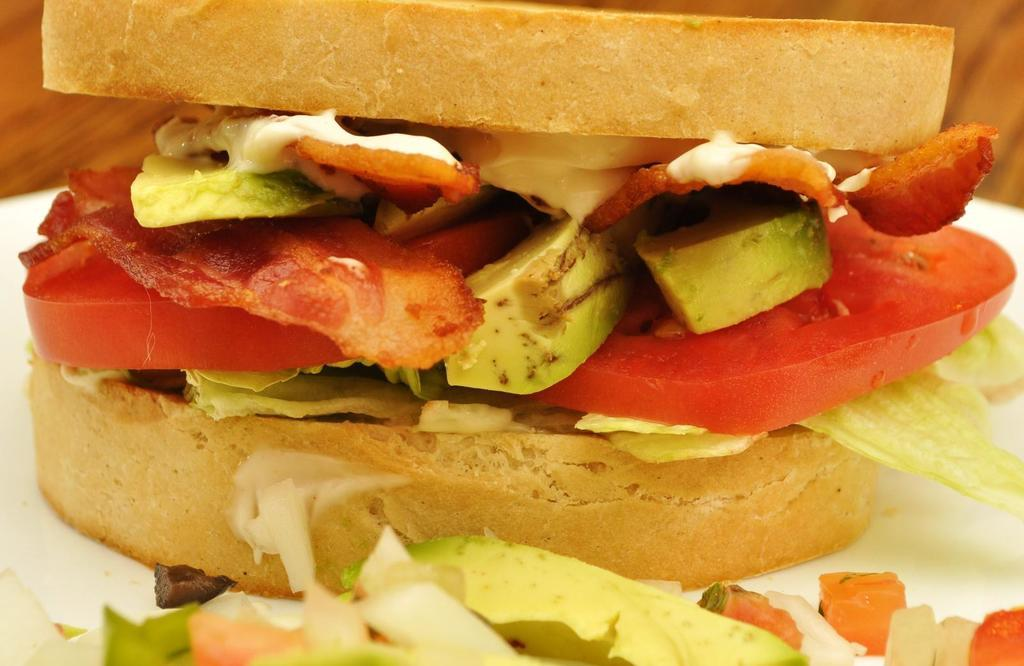What is on the plate that is visible in the image? There are food items on a plate in the image. Can you describe anything else visible in the background of the image? There is a wooden object in the background of the image. What type of sign can be seen hanging from the wooden object in the image? There is no sign present in the image; it only features food items on a plate and a wooden object in the background. 